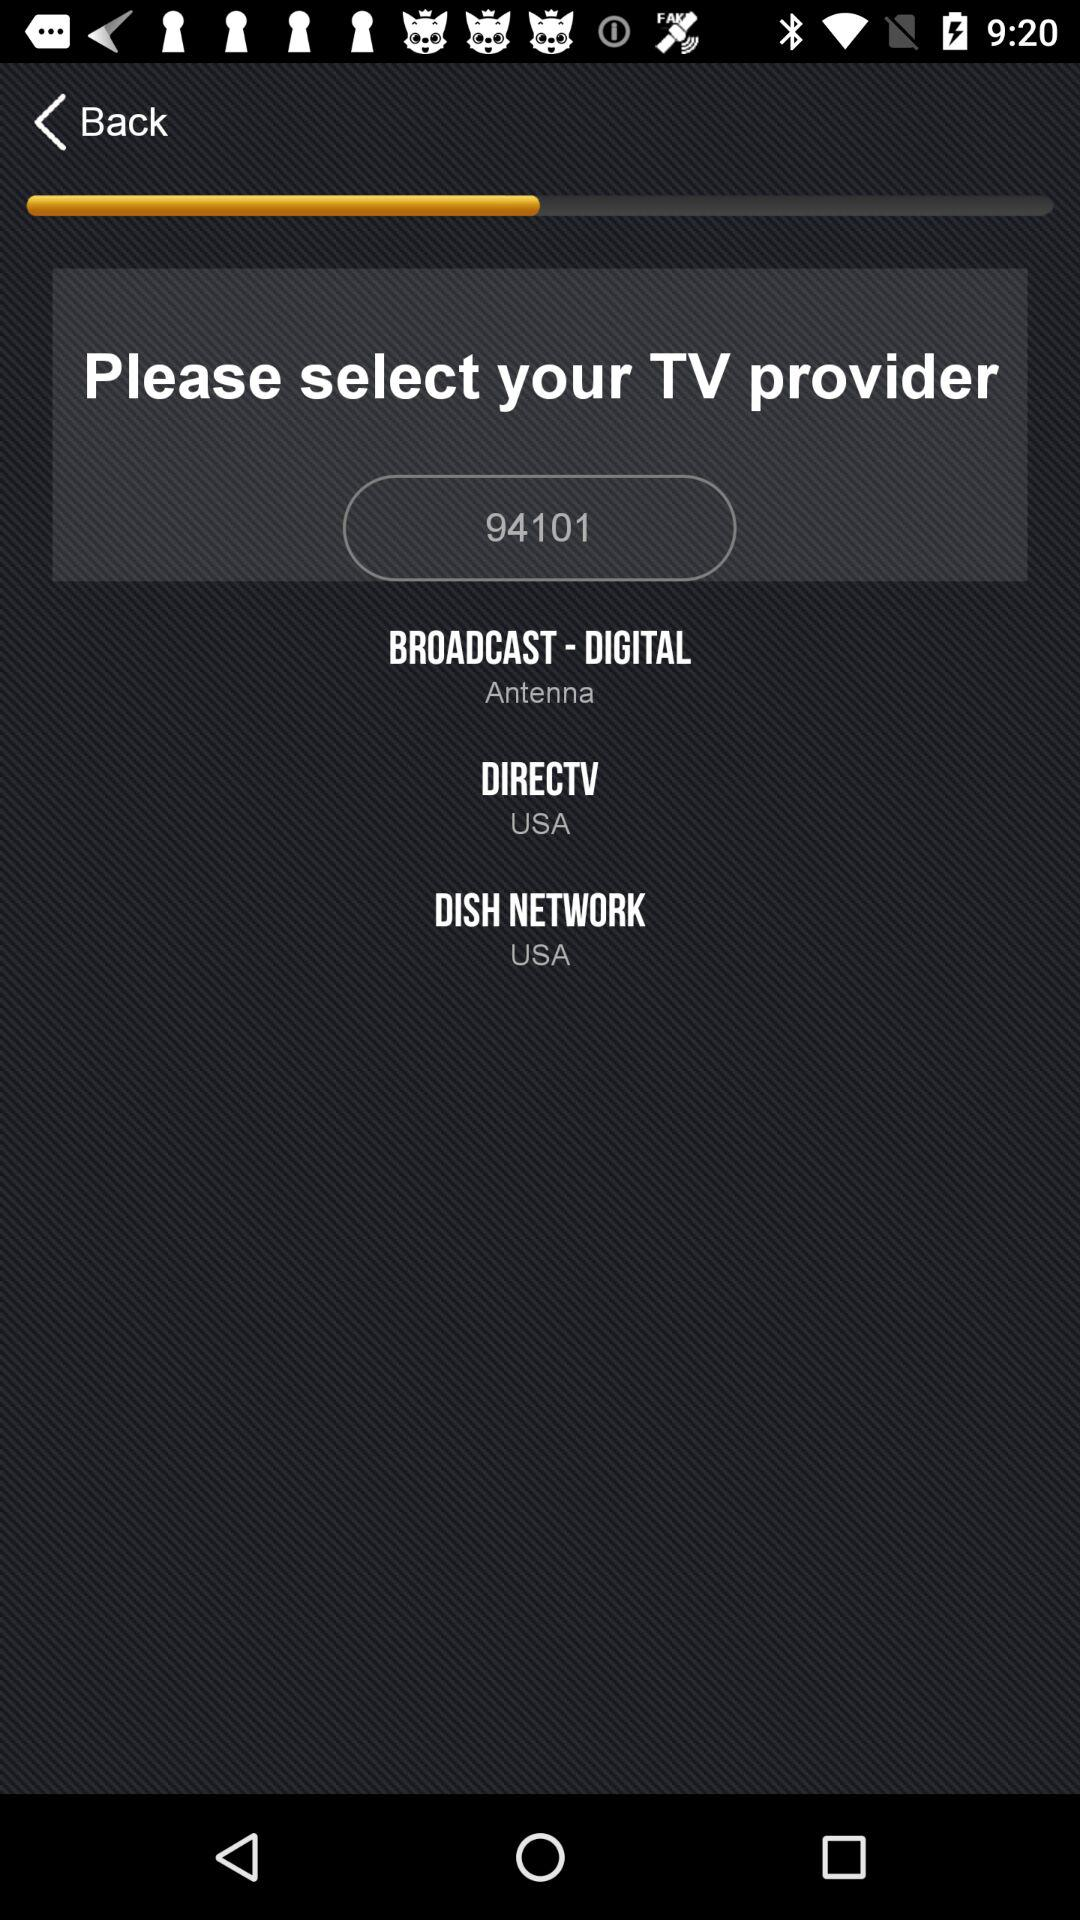What is the chosen broadcast option? The chosen broadcast option is "Antenna". 